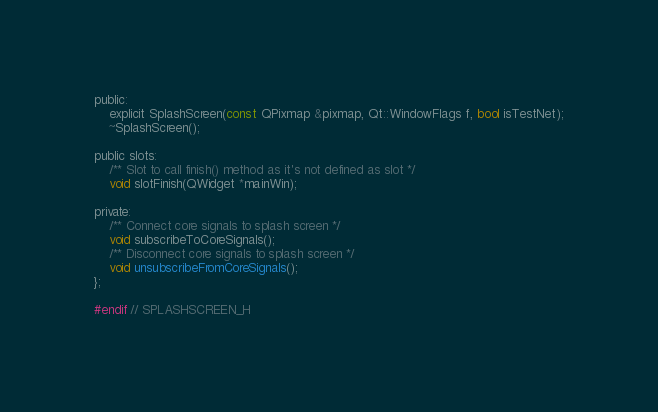<code> <loc_0><loc_0><loc_500><loc_500><_C_>public:
    explicit SplashScreen(const QPixmap &pixmap, Qt::WindowFlags f, bool isTestNet);
    ~SplashScreen();

public slots:
    /** Slot to call finish() method as it's not defined as slot */
    void slotFinish(QWidget *mainWin);

private:
    /** Connect core signals to splash screen */
    void subscribeToCoreSignals();
    /** Disconnect core signals to splash screen */
    void unsubscribeFromCoreSignals();
};

#endif // SPLASHSCREEN_H
</code> 